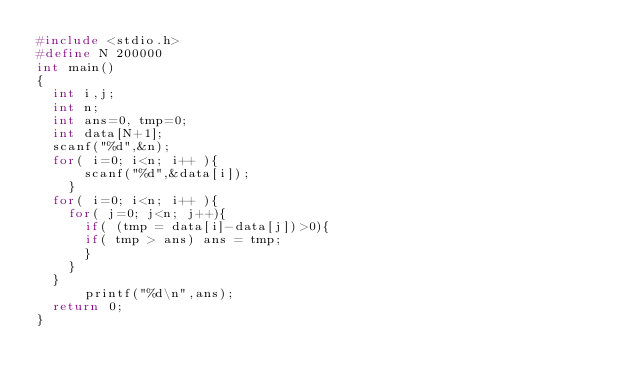<code> <loc_0><loc_0><loc_500><loc_500><_C_>#include <stdio.h>
#define N 200000
int main()
{
  int i,j;
  int n;
  int ans=0, tmp=0;
  int data[N+1];
  scanf("%d",&n);
  for( i=0; i<n; i++ ){
      scanf("%d",&data[i]);
    }
  for( i=0; i<n; i++ ){
    for( j=0; j<n; j++){
      if( (tmp = data[i]-data[j])>0){
      if( tmp > ans) ans = tmp;
      }
    }
  }
      printf("%d\n",ans);
  return 0;
}</code> 